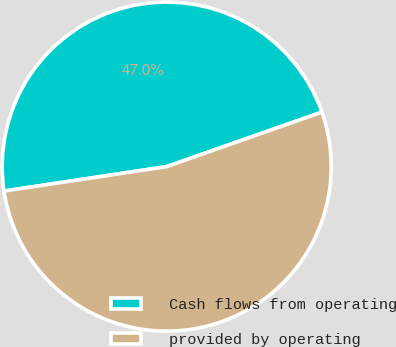Convert chart. <chart><loc_0><loc_0><loc_500><loc_500><pie_chart><fcel>Cash flows from operating<fcel>provided by operating<nl><fcel>47.0%<fcel>53.0%<nl></chart> 